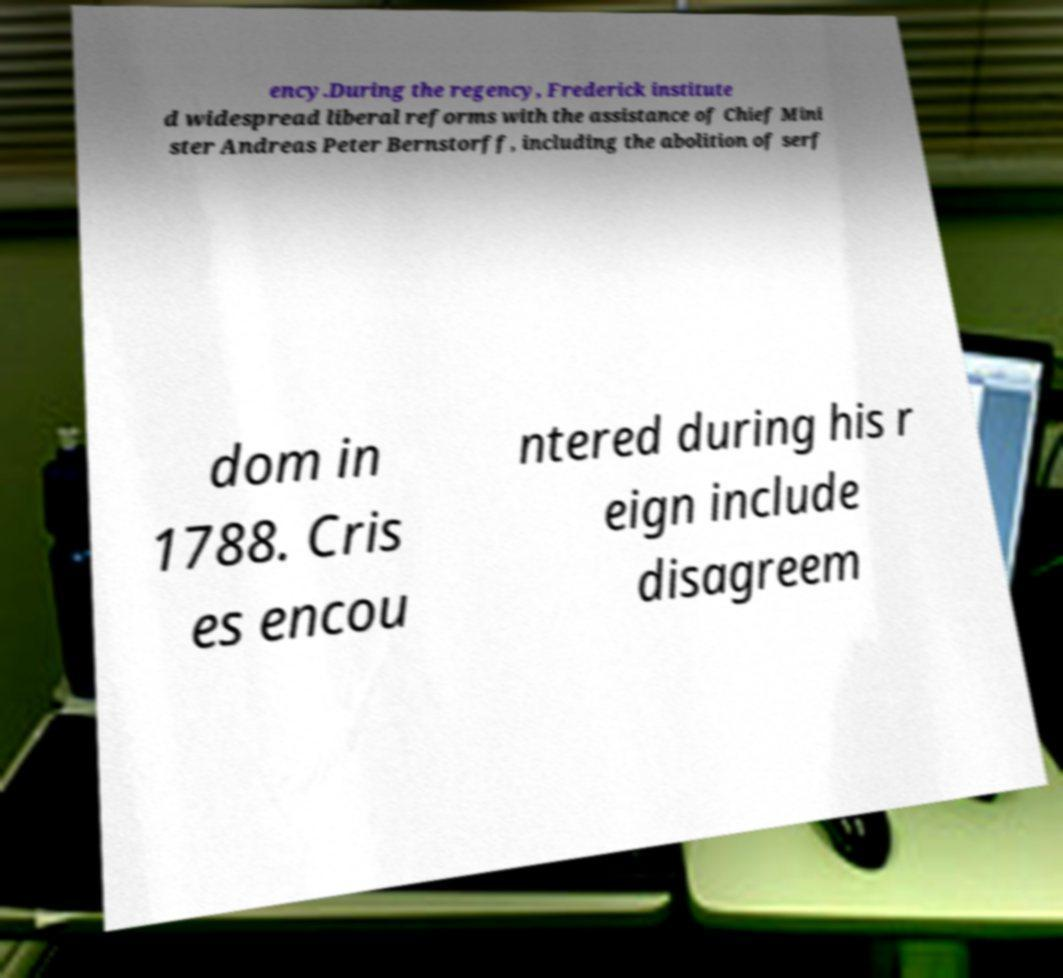I need the written content from this picture converted into text. Can you do that? ency.During the regency, Frederick institute d widespread liberal reforms with the assistance of Chief Mini ster Andreas Peter Bernstorff, including the abolition of serf dom in 1788. Cris es encou ntered during his r eign include disagreem 